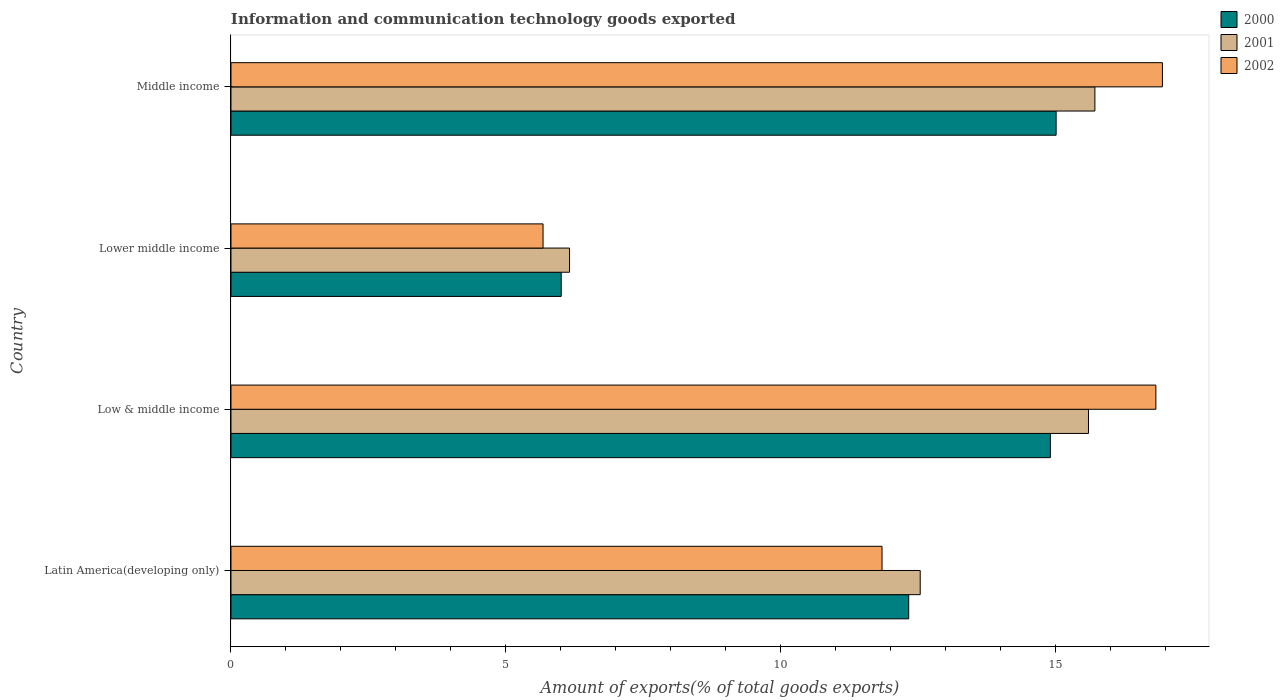Are the number of bars per tick equal to the number of legend labels?
Provide a short and direct response. Yes. Are the number of bars on each tick of the Y-axis equal?
Give a very brief answer. Yes. How many bars are there on the 4th tick from the top?
Your answer should be compact. 3. What is the label of the 2nd group of bars from the top?
Your answer should be very brief. Lower middle income. In how many cases, is the number of bars for a given country not equal to the number of legend labels?
Provide a succinct answer. 0. What is the amount of goods exported in 2000 in Middle income?
Provide a short and direct response. 15.01. Across all countries, what is the maximum amount of goods exported in 2001?
Provide a short and direct response. 15.72. Across all countries, what is the minimum amount of goods exported in 2000?
Provide a succinct answer. 6.01. In which country was the amount of goods exported in 2001 minimum?
Your response must be concise. Lower middle income. What is the total amount of goods exported in 2000 in the graph?
Make the answer very short. 48.25. What is the difference between the amount of goods exported in 2001 in Latin America(developing only) and that in Low & middle income?
Make the answer very short. -3.06. What is the difference between the amount of goods exported in 2000 in Latin America(developing only) and the amount of goods exported in 2001 in Low & middle income?
Provide a succinct answer. -3.27. What is the average amount of goods exported in 2002 per country?
Your answer should be compact. 12.82. What is the difference between the amount of goods exported in 2000 and amount of goods exported in 2002 in Low & middle income?
Your answer should be very brief. -1.92. In how many countries, is the amount of goods exported in 2001 greater than 6 %?
Your answer should be compact. 4. What is the ratio of the amount of goods exported in 2000 in Lower middle income to that in Middle income?
Provide a short and direct response. 0.4. Is the difference between the amount of goods exported in 2000 in Lower middle income and Middle income greater than the difference between the amount of goods exported in 2002 in Lower middle income and Middle income?
Give a very brief answer. Yes. What is the difference between the highest and the second highest amount of goods exported in 2002?
Your answer should be very brief. 0.12. What is the difference between the highest and the lowest amount of goods exported in 2000?
Your answer should be very brief. 9. What does the 2nd bar from the top in Latin America(developing only) represents?
Your response must be concise. 2001. What does the 3rd bar from the bottom in Lower middle income represents?
Make the answer very short. 2002. How many bars are there?
Provide a short and direct response. 12. What is the difference between two consecutive major ticks on the X-axis?
Keep it short and to the point. 5. Are the values on the major ticks of X-axis written in scientific E-notation?
Keep it short and to the point. No. Does the graph contain grids?
Your answer should be very brief. No. How many legend labels are there?
Your answer should be very brief. 3. What is the title of the graph?
Provide a succinct answer. Information and communication technology goods exported. Does "1994" appear as one of the legend labels in the graph?
Give a very brief answer. No. What is the label or title of the X-axis?
Your answer should be very brief. Amount of exports(% of total goods exports). What is the Amount of exports(% of total goods exports) in 2000 in Latin America(developing only)?
Provide a succinct answer. 12.33. What is the Amount of exports(% of total goods exports) of 2001 in Latin America(developing only)?
Make the answer very short. 12.54. What is the Amount of exports(% of total goods exports) of 2002 in Latin America(developing only)?
Offer a terse response. 11.84. What is the Amount of exports(% of total goods exports) of 2000 in Low & middle income?
Your answer should be very brief. 14.91. What is the Amount of exports(% of total goods exports) in 2001 in Low & middle income?
Make the answer very short. 15.6. What is the Amount of exports(% of total goods exports) of 2002 in Low & middle income?
Ensure brevity in your answer.  16.82. What is the Amount of exports(% of total goods exports) in 2000 in Lower middle income?
Your answer should be very brief. 6.01. What is the Amount of exports(% of total goods exports) in 2001 in Lower middle income?
Your answer should be compact. 6.16. What is the Amount of exports(% of total goods exports) of 2002 in Lower middle income?
Make the answer very short. 5.68. What is the Amount of exports(% of total goods exports) in 2000 in Middle income?
Offer a terse response. 15.01. What is the Amount of exports(% of total goods exports) in 2001 in Middle income?
Ensure brevity in your answer.  15.72. What is the Amount of exports(% of total goods exports) in 2002 in Middle income?
Provide a succinct answer. 16.94. Across all countries, what is the maximum Amount of exports(% of total goods exports) of 2000?
Offer a very short reply. 15.01. Across all countries, what is the maximum Amount of exports(% of total goods exports) in 2001?
Your answer should be very brief. 15.72. Across all countries, what is the maximum Amount of exports(% of total goods exports) in 2002?
Provide a short and direct response. 16.94. Across all countries, what is the minimum Amount of exports(% of total goods exports) in 2000?
Your answer should be compact. 6.01. Across all countries, what is the minimum Amount of exports(% of total goods exports) in 2001?
Provide a succinct answer. 6.16. Across all countries, what is the minimum Amount of exports(% of total goods exports) of 2002?
Make the answer very short. 5.68. What is the total Amount of exports(% of total goods exports) of 2000 in the graph?
Provide a short and direct response. 48.25. What is the total Amount of exports(% of total goods exports) in 2001 in the graph?
Your answer should be compact. 50.01. What is the total Amount of exports(% of total goods exports) in 2002 in the graph?
Ensure brevity in your answer.  51.29. What is the difference between the Amount of exports(% of total goods exports) in 2000 in Latin America(developing only) and that in Low & middle income?
Keep it short and to the point. -2.58. What is the difference between the Amount of exports(% of total goods exports) of 2001 in Latin America(developing only) and that in Low & middle income?
Provide a succinct answer. -3.06. What is the difference between the Amount of exports(% of total goods exports) in 2002 in Latin America(developing only) and that in Low & middle income?
Give a very brief answer. -4.98. What is the difference between the Amount of exports(% of total goods exports) of 2000 in Latin America(developing only) and that in Lower middle income?
Provide a short and direct response. 6.32. What is the difference between the Amount of exports(% of total goods exports) of 2001 in Latin America(developing only) and that in Lower middle income?
Make the answer very short. 6.38. What is the difference between the Amount of exports(% of total goods exports) in 2002 in Latin America(developing only) and that in Lower middle income?
Ensure brevity in your answer.  6.17. What is the difference between the Amount of exports(% of total goods exports) of 2000 in Latin America(developing only) and that in Middle income?
Give a very brief answer. -2.68. What is the difference between the Amount of exports(% of total goods exports) in 2001 in Latin America(developing only) and that in Middle income?
Your answer should be compact. -3.18. What is the difference between the Amount of exports(% of total goods exports) in 2002 in Latin America(developing only) and that in Middle income?
Make the answer very short. -5.1. What is the difference between the Amount of exports(% of total goods exports) in 2000 in Low & middle income and that in Lower middle income?
Make the answer very short. 8.9. What is the difference between the Amount of exports(% of total goods exports) in 2001 in Low & middle income and that in Lower middle income?
Your answer should be compact. 9.44. What is the difference between the Amount of exports(% of total goods exports) of 2002 in Low & middle income and that in Lower middle income?
Provide a succinct answer. 11.15. What is the difference between the Amount of exports(% of total goods exports) in 2000 in Low & middle income and that in Middle income?
Your response must be concise. -0.1. What is the difference between the Amount of exports(% of total goods exports) of 2001 in Low & middle income and that in Middle income?
Your answer should be very brief. -0.12. What is the difference between the Amount of exports(% of total goods exports) of 2002 in Low & middle income and that in Middle income?
Your answer should be compact. -0.12. What is the difference between the Amount of exports(% of total goods exports) of 2000 in Lower middle income and that in Middle income?
Ensure brevity in your answer.  -9. What is the difference between the Amount of exports(% of total goods exports) in 2001 in Lower middle income and that in Middle income?
Keep it short and to the point. -9.56. What is the difference between the Amount of exports(% of total goods exports) of 2002 in Lower middle income and that in Middle income?
Provide a short and direct response. -11.27. What is the difference between the Amount of exports(% of total goods exports) of 2000 in Latin America(developing only) and the Amount of exports(% of total goods exports) of 2001 in Low & middle income?
Offer a very short reply. -3.27. What is the difference between the Amount of exports(% of total goods exports) in 2000 in Latin America(developing only) and the Amount of exports(% of total goods exports) in 2002 in Low & middle income?
Your answer should be compact. -4.5. What is the difference between the Amount of exports(% of total goods exports) in 2001 in Latin America(developing only) and the Amount of exports(% of total goods exports) in 2002 in Low & middle income?
Offer a terse response. -4.29. What is the difference between the Amount of exports(% of total goods exports) of 2000 in Latin America(developing only) and the Amount of exports(% of total goods exports) of 2001 in Lower middle income?
Ensure brevity in your answer.  6.17. What is the difference between the Amount of exports(% of total goods exports) in 2000 in Latin America(developing only) and the Amount of exports(% of total goods exports) in 2002 in Lower middle income?
Ensure brevity in your answer.  6.65. What is the difference between the Amount of exports(% of total goods exports) in 2001 in Latin America(developing only) and the Amount of exports(% of total goods exports) in 2002 in Lower middle income?
Make the answer very short. 6.86. What is the difference between the Amount of exports(% of total goods exports) in 2000 in Latin America(developing only) and the Amount of exports(% of total goods exports) in 2001 in Middle income?
Your response must be concise. -3.39. What is the difference between the Amount of exports(% of total goods exports) of 2000 in Latin America(developing only) and the Amount of exports(% of total goods exports) of 2002 in Middle income?
Offer a terse response. -4.62. What is the difference between the Amount of exports(% of total goods exports) of 2001 in Latin America(developing only) and the Amount of exports(% of total goods exports) of 2002 in Middle income?
Your response must be concise. -4.41. What is the difference between the Amount of exports(% of total goods exports) of 2000 in Low & middle income and the Amount of exports(% of total goods exports) of 2001 in Lower middle income?
Offer a terse response. 8.75. What is the difference between the Amount of exports(% of total goods exports) in 2000 in Low & middle income and the Amount of exports(% of total goods exports) in 2002 in Lower middle income?
Your response must be concise. 9.23. What is the difference between the Amount of exports(% of total goods exports) of 2001 in Low & middle income and the Amount of exports(% of total goods exports) of 2002 in Lower middle income?
Your answer should be compact. 9.92. What is the difference between the Amount of exports(% of total goods exports) in 2000 in Low & middle income and the Amount of exports(% of total goods exports) in 2001 in Middle income?
Your answer should be compact. -0.81. What is the difference between the Amount of exports(% of total goods exports) in 2000 in Low & middle income and the Amount of exports(% of total goods exports) in 2002 in Middle income?
Offer a very short reply. -2.04. What is the difference between the Amount of exports(% of total goods exports) in 2001 in Low & middle income and the Amount of exports(% of total goods exports) in 2002 in Middle income?
Your answer should be compact. -1.34. What is the difference between the Amount of exports(% of total goods exports) of 2000 in Lower middle income and the Amount of exports(% of total goods exports) of 2001 in Middle income?
Make the answer very short. -9.71. What is the difference between the Amount of exports(% of total goods exports) in 2000 in Lower middle income and the Amount of exports(% of total goods exports) in 2002 in Middle income?
Offer a terse response. -10.94. What is the difference between the Amount of exports(% of total goods exports) in 2001 in Lower middle income and the Amount of exports(% of total goods exports) in 2002 in Middle income?
Provide a short and direct response. -10.78. What is the average Amount of exports(% of total goods exports) in 2000 per country?
Your answer should be very brief. 12.06. What is the average Amount of exports(% of total goods exports) of 2001 per country?
Offer a very short reply. 12.5. What is the average Amount of exports(% of total goods exports) in 2002 per country?
Ensure brevity in your answer.  12.82. What is the difference between the Amount of exports(% of total goods exports) in 2000 and Amount of exports(% of total goods exports) in 2001 in Latin America(developing only)?
Provide a succinct answer. -0.21. What is the difference between the Amount of exports(% of total goods exports) of 2000 and Amount of exports(% of total goods exports) of 2002 in Latin America(developing only)?
Keep it short and to the point. 0.49. What is the difference between the Amount of exports(% of total goods exports) in 2001 and Amount of exports(% of total goods exports) in 2002 in Latin America(developing only)?
Offer a very short reply. 0.69. What is the difference between the Amount of exports(% of total goods exports) of 2000 and Amount of exports(% of total goods exports) of 2001 in Low & middle income?
Keep it short and to the point. -0.69. What is the difference between the Amount of exports(% of total goods exports) in 2000 and Amount of exports(% of total goods exports) in 2002 in Low & middle income?
Keep it short and to the point. -1.92. What is the difference between the Amount of exports(% of total goods exports) of 2001 and Amount of exports(% of total goods exports) of 2002 in Low & middle income?
Your answer should be very brief. -1.23. What is the difference between the Amount of exports(% of total goods exports) of 2000 and Amount of exports(% of total goods exports) of 2001 in Lower middle income?
Your answer should be very brief. -0.15. What is the difference between the Amount of exports(% of total goods exports) in 2000 and Amount of exports(% of total goods exports) in 2002 in Lower middle income?
Give a very brief answer. 0.33. What is the difference between the Amount of exports(% of total goods exports) in 2001 and Amount of exports(% of total goods exports) in 2002 in Lower middle income?
Provide a succinct answer. 0.48. What is the difference between the Amount of exports(% of total goods exports) of 2000 and Amount of exports(% of total goods exports) of 2001 in Middle income?
Your answer should be compact. -0.71. What is the difference between the Amount of exports(% of total goods exports) of 2000 and Amount of exports(% of total goods exports) of 2002 in Middle income?
Your answer should be very brief. -1.93. What is the difference between the Amount of exports(% of total goods exports) of 2001 and Amount of exports(% of total goods exports) of 2002 in Middle income?
Provide a succinct answer. -1.23. What is the ratio of the Amount of exports(% of total goods exports) in 2000 in Latin America(developing only) to that in Low & middle income?
Provide a short and direct response. 0.83. What is the ratio of the Amount of exports(% of total goods exports) of 2001 in Latin America(developing only) to that in Low & middle income?
Your answer should be very brief. 0.8. What is the ratio of the Amount of exports(% of total goods exports) of 2002 in Latin America(developing only) to that in Low & middle income?
Your answer should be very brief. 0.7. What is the ratio of the Amount of exports(% of total goods exports) of 2000 in Latin America(developing only) to that in Lower middle income?
Your answer should be compact. 2.05. What is the ratio of the Amount of exports(% of total goods exports) in 2001 in Latin America(developing only) to that in Lower middle income?
Your answer should be very brief. 2.04. What is the ratio of the Amount of exports(% of total goods exports) of 2002 in Latin America(developing only) to that in Lower middle income?
Offer a very short reply. 2.09. What is the ratio of the Amount of exports(% of total goods exports) in 2000 in Latin America(developing only) to that in Middle income?
Provide a succinct answer. 0.82. What is the ratio of the Amount of exports(% of total goods exports) of 2001 in Latin America(developing only) to that in Middle income?
Provide a short and direct response. 0.8. What is the ratio of the Amount of exports(% of total goods exports) of 2002 in Latin America(developing only) to that in Middle income?
Keep it short and to the point. 0.7. What is the ratio of the Amount of exports(% of total goods exports) in 2000 in Low & middle income to that in Lower middle income?
Give a very brief answer. 2.48. What is the ratio of the Amount of exports(% of total goods exports) in 2001 in Low & middle income to that in Lower middle income?
Provide a succinct answer. 2.53. What is the ratio of the Amount of exports(% of total goods exports) of 2002 in Low & middle income to that in Lower middle income?
Your answer should be compact. 2.96. What is the ratio of the Amount of exports(% of total goods exports) of 2001 in Low & middle income to that in Middle income?
Ensure brevity in your answer.  0.99. What is the ratio of the Amount of exports(% of total goods exports) in 2002 in Low & middle income to that in Middle income?
Ensure brevity in your answer.  0.99. What is the ratio of the Amount of exports(% of total goods exports) of 2000 in Lower middle income to that in Middle income?
Your answer should be very brief. 0.4. What is the ratio of the Amount of exports(% of total goods exports) of 2001 in Lower middle income to that in Middle income?
Your answer should be very brief. 0.39. What is the ratio of the Amount of exports(% of total goods exports) of 2002 in Lower middle income to that in Middle income?
Offer a terse response. 0.34. What is the difference between the highest and the second highest Amount of exports(% of total goods exports) of 2000?
Your answer should be compact. 0.1. What is the difference between the highest and the second highest Amount of exports(% of total goods exports) of 2001?
Offer a very short reply. 0.12. What is the difference between the highest and the second highest Amount of exports(% of total goods exports) in 2002?
Make the answer very short. 0.12. What is the difference between the highest and the lowest Amount of exports(% of total goods exports) in 2000?
Offer a very short reply. 9. What is the difference between the highest and the lowest Amount of exports(% of total goods exports) of 2001?
Ensure brevity in your answer.  9.56. What is the difference between the highest and the lowest Amount of exports(% of total goods exports) of 2002?
Make the answer very short. 11.27. 